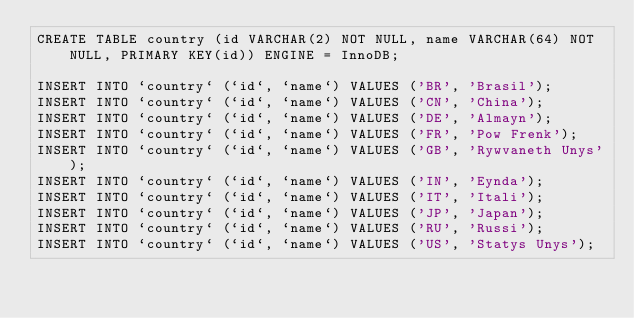Convert code to text. <code><loc_0><loc_0><loc_500><loc_500><_SQL_>CREATE TABLE country (id VARCHAR(2) NOT NULL, name VARCHAR(64) NOT NULL, PRIMARY KEY(id)) ENGINE = InnoDB;

INSERT INTO `country` (`id`, `name`) VALUES ('BR', 'Brasil');
INSERT INTO `country` (`id`, `name`) VALUES ('CN', 'China');
INSERT INTO `country` (`id`, `name`) VALUES ('DE', 'Almayn');
INSERT INTO `country` (`id`, `name`) VALUES ('FR', 'Pow Frenk');
INSERT INTO `country` (`id`, `name`) VALUES ('GB', 'Rywvaneth Unys');
INSERT INTO `country` (`id`, `name`) VALUES ('IN', 'Eynda');
INSERT INTO `country` (`id`, `name`) VALUES ('IT', 'Itali');
INSERT INTO `country` (`id`, `name`) VALUES ('JP', 'Japan');
INSERT INTO `country` (`id`, `name`) VALUES ('RU', 'Russi');
INSERT INTO `country` (`id`, `name`) VALUES ('US', 'Statys Unys');
</code> 